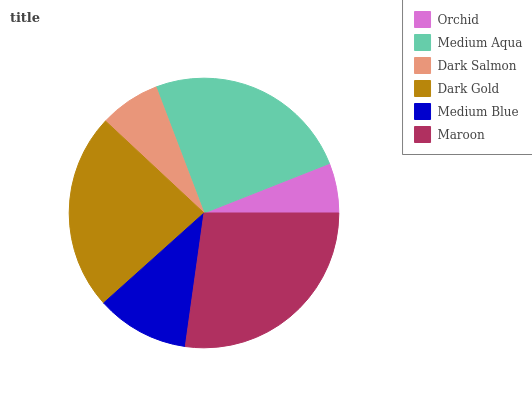Is Orchid the minimum?
Answer yes or no. Yes. Is Maroon the maximum?
Answer yes or no. Yes. Is Medium Aqua the minimum?
Answer yes or no. No. Is Medium Aqua the maximum?
Answer yes or no. No. Is Medium Aqua greater than Orchid?
Answer yes or no. Yes. Is Orchid less than Medium Aqua?
Answer yes or no. Yes. Is Orchid greater than Medium Aqua?
Answer yes or no. No. Is Medium Aqua less than Orchid?
Answer yes or no. No. Is Dark Gold the high median?
Answer yes or no. Yes. Is Medium Blue the low median?
Answer yes or no. Yes. Is Medium Blue the high median?
Answer yes or no. No. Is Dark Salmon the low median?
Answer yes or no. No. 